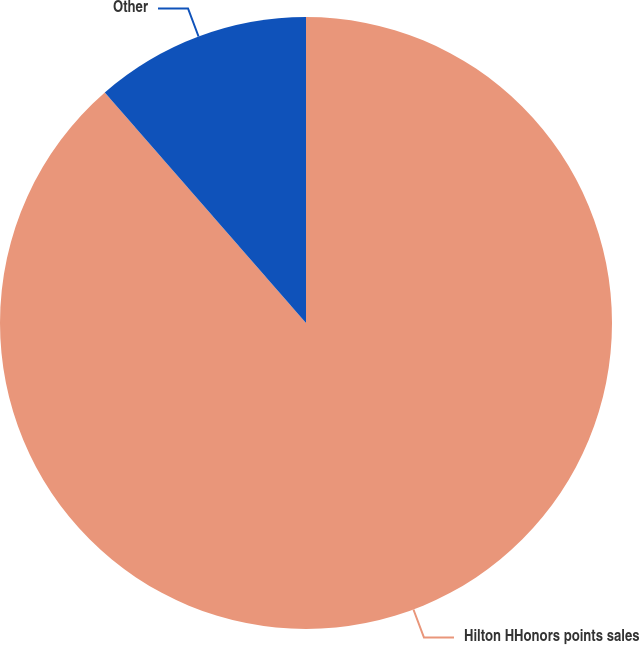Convert chart. <chart><loc_0><loc_0><loc_500><loc_500><pie_chart><fcel>Hilton HHonors points sales<fcel>Other<nl><fcel>88.58%<fcel>11.42%<nl></chart> 